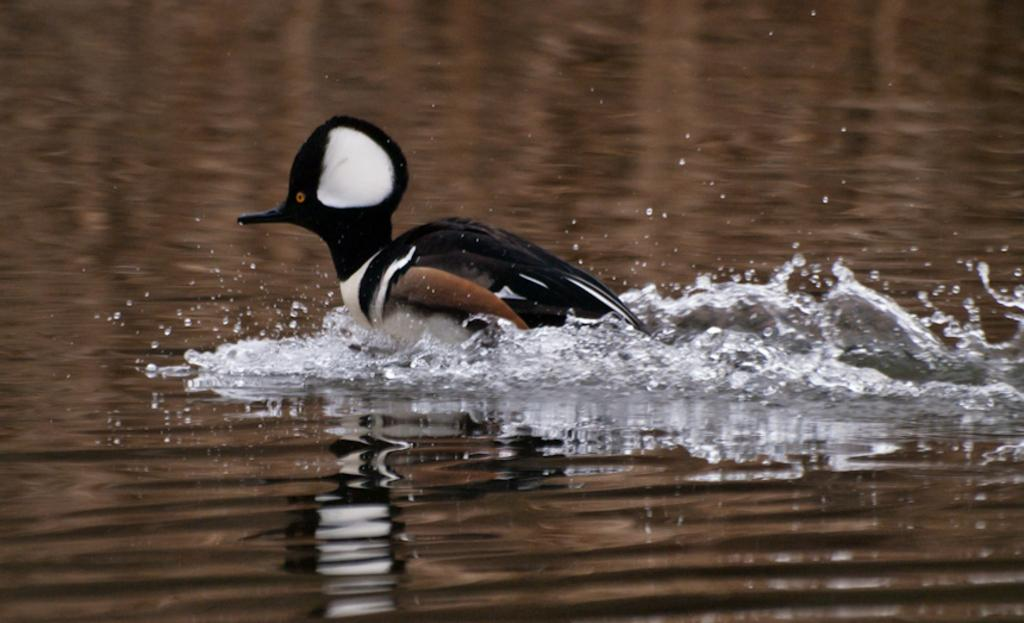What type of animal is in the image? There is a bird in the image. Can you describe the bird's coloring? The bird has off-white, black, and brown coloring. What else can be seen in the image besides the bird? There is water visible in the image. How many pizzas are being held by the person in the image? There is no person present in the image, and therefore no pizzas can be held by a person. 